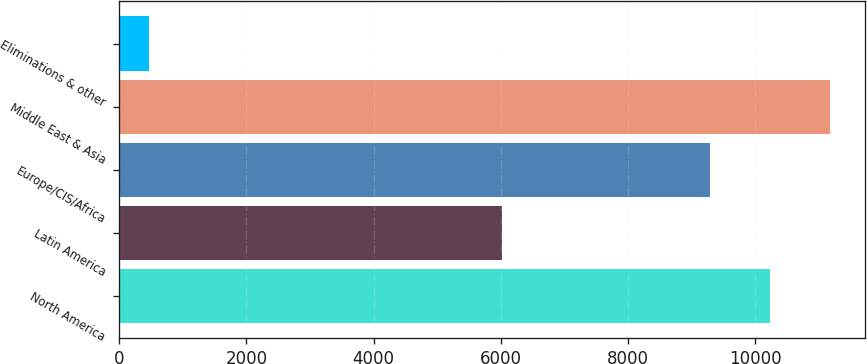Convert chart to OTSL. <chart><loc_0><loc_0><loc_500><loc_500><bar_chart><fcel>North America<fcel>Latin America<fcel>Europe/CIS/Africa<fcel>Middle East & Asia<fcel>Eliminations & other<nl><fcel>10227<fcel>6014<fcel>9284<fcel>11170<fcel>468<nl></chart> 